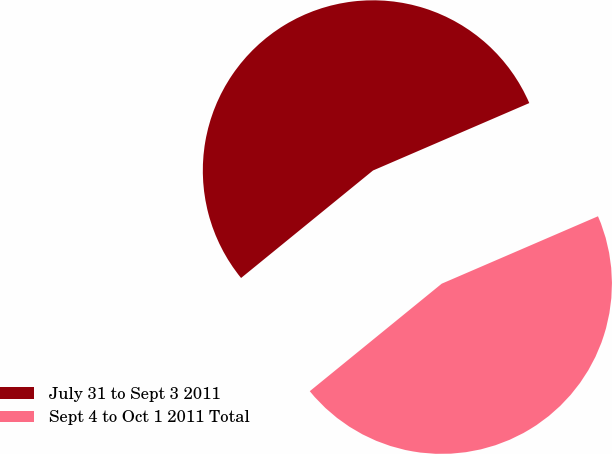Convert chart. <chart><loc_0><loc_0><loc_500><loc_500><pie_chart><fcel>July 31 to Sept 3 2011<fcel>Sept 4 to Oct 1 2011 Total<nl><fcel>54.4%<fcel>45.6%<nl></chart> 